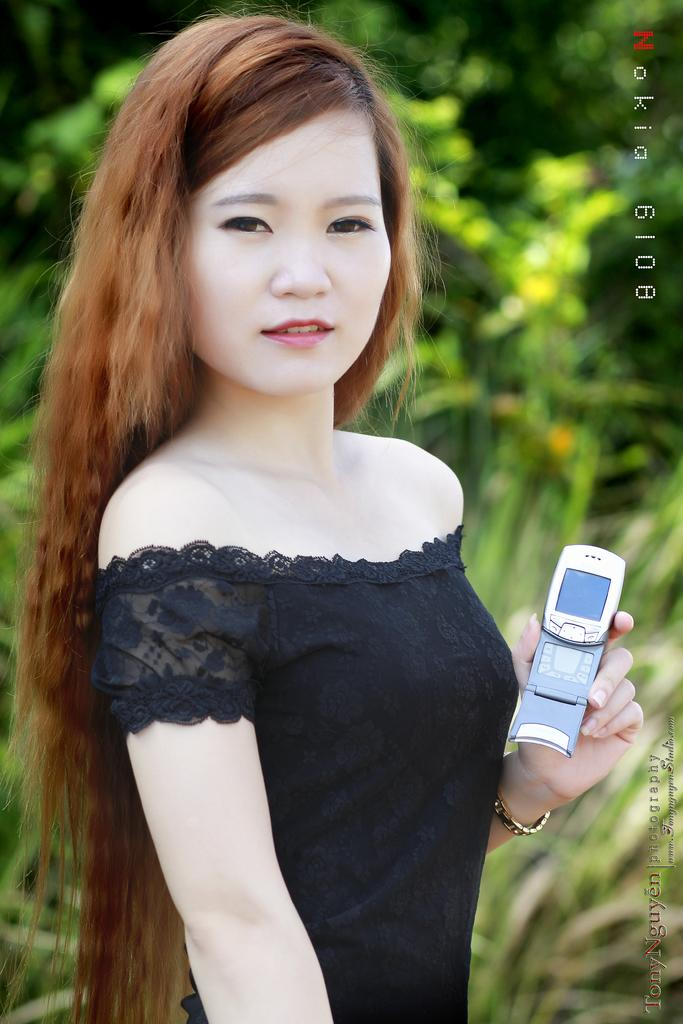Who is the main subject in the image? There is a lady in the center of the image. What is the lady holding in the image? The lady is holding a mobile. What can be seen in the background of the image? There are trees in the background of the image. Is there any text visible in the image? Yes, there is some text visible in the image. What type of amusement can be seen in the image? There is no amusement present in the image; it features a lady holding a mobile with trees in the background and some text visible. How many boys are visible in the image? There are no boys present in the image; it features a lady holding a mobile with trees in the background and some text visible. 